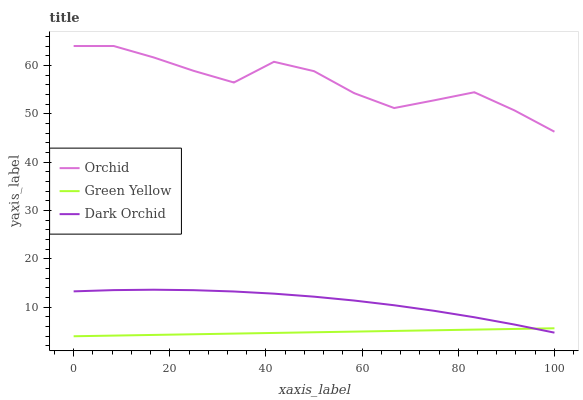Does Green Yellow have the minimum area under the curve?
Answer yes or no. Yes. Does Orchid have the maximum area under the curve?
Answer yes or no. Yes. Does Dark Orchid have the minimum area under the curve?
Answer yes or no. No. Does Dark Orchid have the maximum area under the curve?
Answer yes or no. No. Is Green Yellow the smoothest?
Answer yes or no. Yes. Is Orchid the roughest?
Answer yes or no. Yes. Is Dark Orchid the smoothest?
Answer yes or no. No. Is Dark Orchid the roughest?
Answer yes or no. No. Does Green Yellow have the lowest value?
Answer yes or no. Yes. Does Dark Orchid have the lowest value?
Answer yes or no. No. Does Orchid have the highest value?
Answer yes or no. Yes. Does Dark Orchid have the highest value?
Answer yes or no. No. Is Green Yellow less than Orchid?
Answer yes or no. Yes. Is Orchid greater than Dark Orchid?
Answer yes or no. Yes. Does Dark Orchid intersect Green Yellow?
Answer yes or no. Yes. Is Dark Orchid less than Green Yellow?
Answer yes or no. No. Is Dark Orchid greater than Green Yellow?
Answer yes or no. No. Does Green Yellow intersect Orchid?
Answer yes or no. No. 